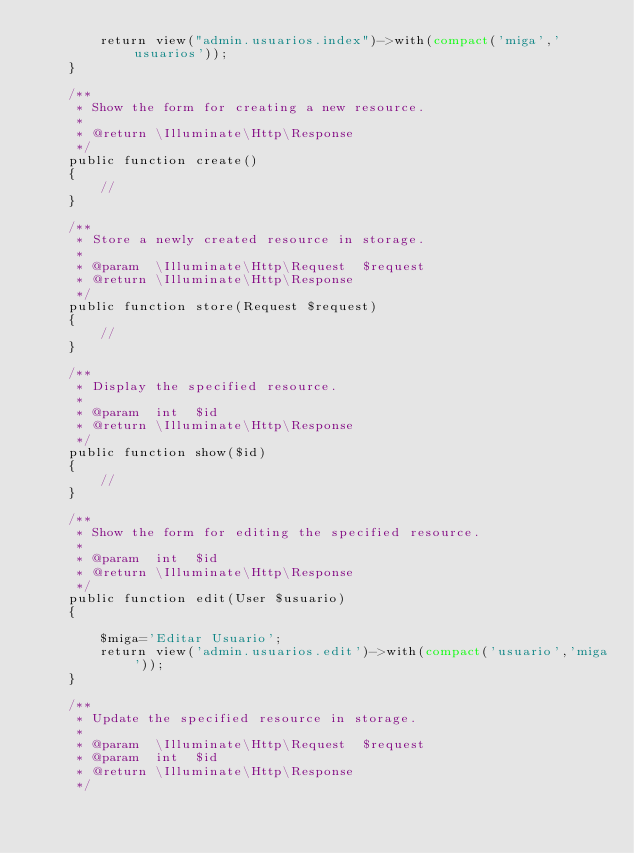Convert code to text. <code><loc_0><loc_0><loc_500><loc_500><_PHP_>        return view("admin.usuarios.index")->with(compact('miga','usuarios'));
    }

    /**
     * Show the form for creating a new resource.
     *
     * @return \Illuminate\Http\Response
     */
    public function create()
    {
        //
    }

    /**
     * Store a newly created resource in storage.
     *
     * @param  \Illuminate\Http\Request  $request
     * @return \Illuminate\Http\Response
     */
    public function store(Request $request)
    {
        //
    }

    /**
     * Display the specified resource.
     *
     * @param  int  $id
     * @return \Illuminate\Http\Response
     */
    public function show($id)
    {
        //
    }

    /**
     * Show the form for editing the specified resource.
     *
     * @param  int  $id
     * @return \Illuminate\Http\Response
     */
    public function edit(User $usuario)
    {
       
        $miga='Editar Usuario';
        return view('admin.usuarios.edit')->with(compact('usuario','miga'));
    }

    /**
     * Update the specified resource in storage.
     *
     * @param  \Illuminate\Http\Request  $request
     * @param  int  $id
     * @return \Illuminate\Http\Response
     */</code> 